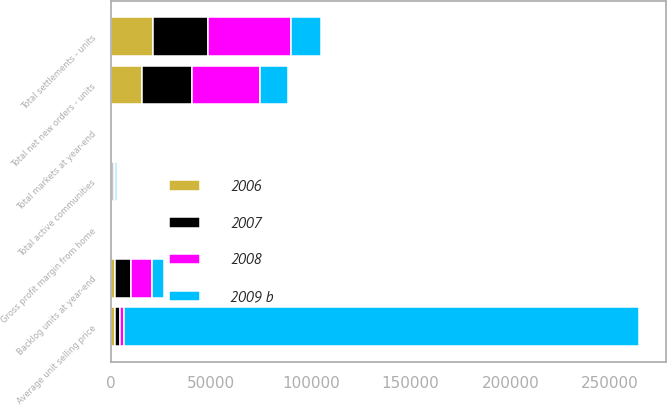Convert chart to OTSL. <chart><loc_0><loc_0><loc_500><loc_500><stacked_bar_chart><ecel><fcel>Total markets at year-end<fcel>Total active communities<fcel>Total settlements - units<fcel>Total net new orders - units<fcel>Backlog units at year-end<fcel>Average unit selling price<fcel>Gross profit margin from home<nl><fcel>2009 b<fcel>69<fcel>882<fcel>15013<fcel>14185<fcel>5931<fcel>258000<fcel>10.5<nl><fcel>2006<fcel>49<fcel>572<fcel>21022<fcel>15306<fcel>2174<fcel>2174<fcel>10.1<nl><fcel>2007<fcel>51<fcel>737<fcel>27540<fcel>25175<fcel>7890<fcel>2174<fcel>5<nl><fcel>2008<fcel>52<fcel>767<fcel>41487<fcel>33925<fcel>10255<fcel>2174<fcel>17.4<nl></chart> 